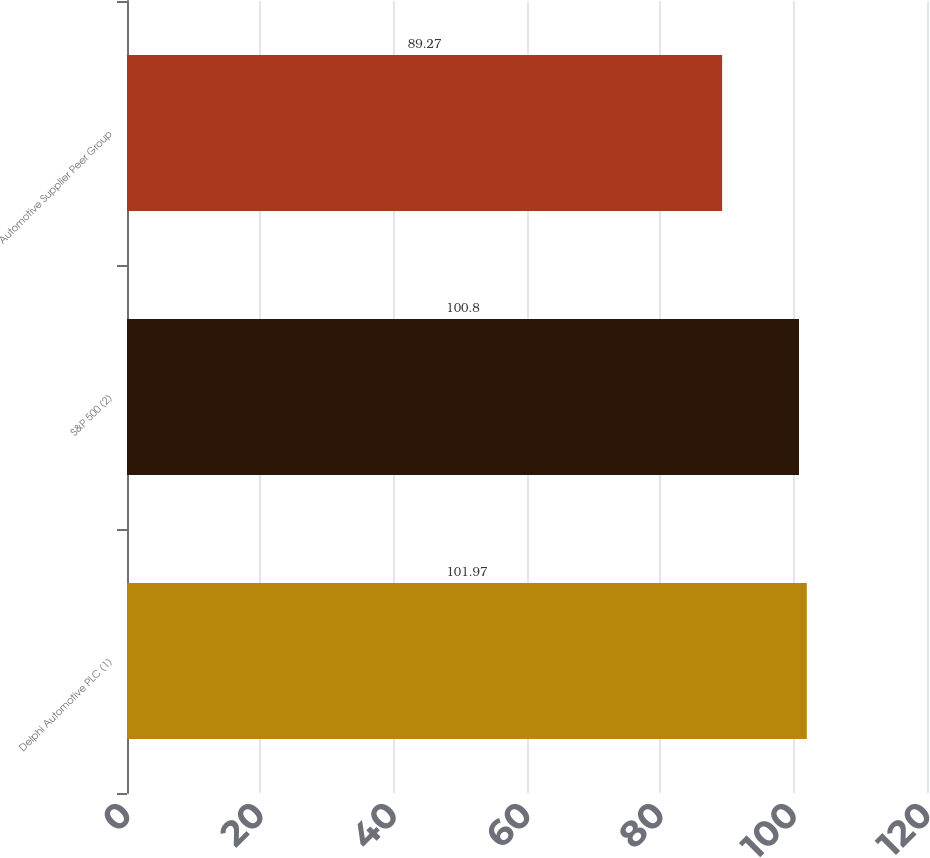<chart> <loc_0><loc_0><loc_500><loc_500><bar_chart><fcel>Delphi Automotive PLC (1)<fcel>S&P 500 (2)<fcel>Automotive Supplier Peer Group<nl><fcel>101.97<fcel>100.8<fcel>89.27<nl></chart> 